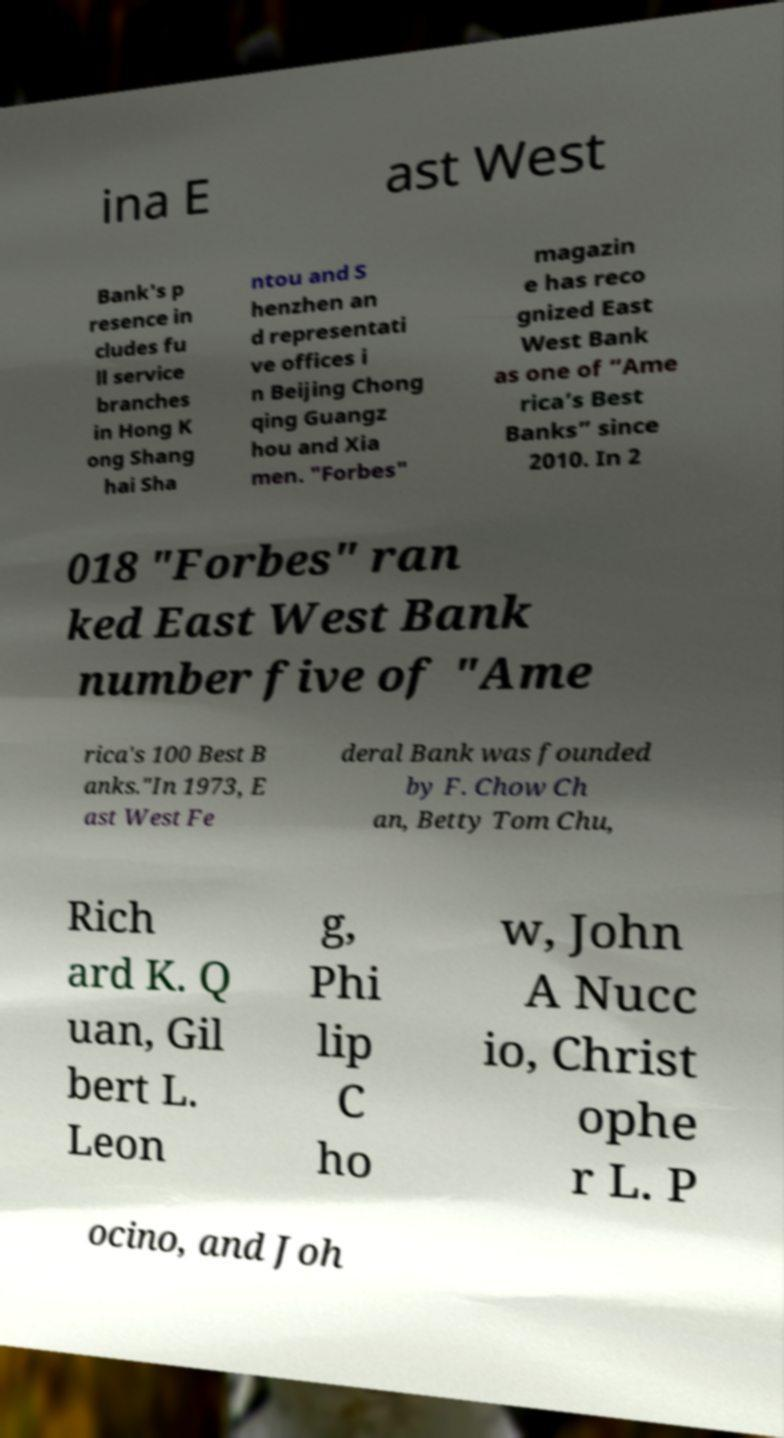Could you extract and type out the text from this image? ina E ast West Bank's p resence in cludes fu ll service branches in Hong K ong Shang hai Sha ntou and S henzhen an d representati ve offices i n Beijing Chong qing Guangz hou and Xia men. "Forbes" magazin e has reco gnized East West Bank as one of “Ame rica’s Best Banks” since 2010. In 2 018 "Forbes" ran ked East West Bank number five of "Ame rica's 100 Best B anks."In 1973, E ast West Fe deral Bank was founded by F. Chow Ch an, Betty Tom Chu, Rich ard K. Q uan, Gil bert L. Leon g, Phi lip C ho w, John A Nucc io, Christ ophe r L. P ocino, and Joh 